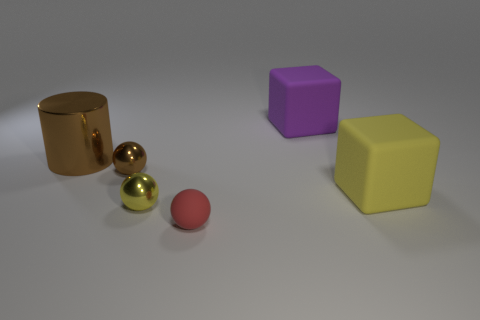Are there any cylinders?
Make the answer very short. Yes. Does the yellow object that is to the right of the small red matte thing have the same material as the red ball that is in front of the big yellow matte cube?
Your answer should be very brief. Yes. What is the shape of the tiny thing that is the same color as the big cylinder?
Provide a short and direct response. Sphere. How many objects are objects that are to the right of the brown metal ball or yellow things on the left side of the purple rubber object?
Offer a terse response. 4. There is a shiny thing that is on the right side of the tiny brown shiny sphere; does it have the same color as the big object that is in front of the tiny brown shiny object?
Provide a succinct answer. Yes. There is a rubber object that is in front of the cylinder and to the left of the yellow matte block; what shape is it?
Provide a short and direct response. Sphere. What color is the block that is the same size as the purple thing?
Your response must be concise. Yellow. Are there any balls that have the same color as the shiny cylinder?
Give a very brief answer. Yes. Does the matte block that is behind the big shiny thing have the same size as the sphere that is on the left side of the small yellow metallic sphere?
Provide a succinct answer. No. There is a thing that is behind the small brown thing and right of the large brown thing; what is it made of?
Offer a terse response. Rubber. 